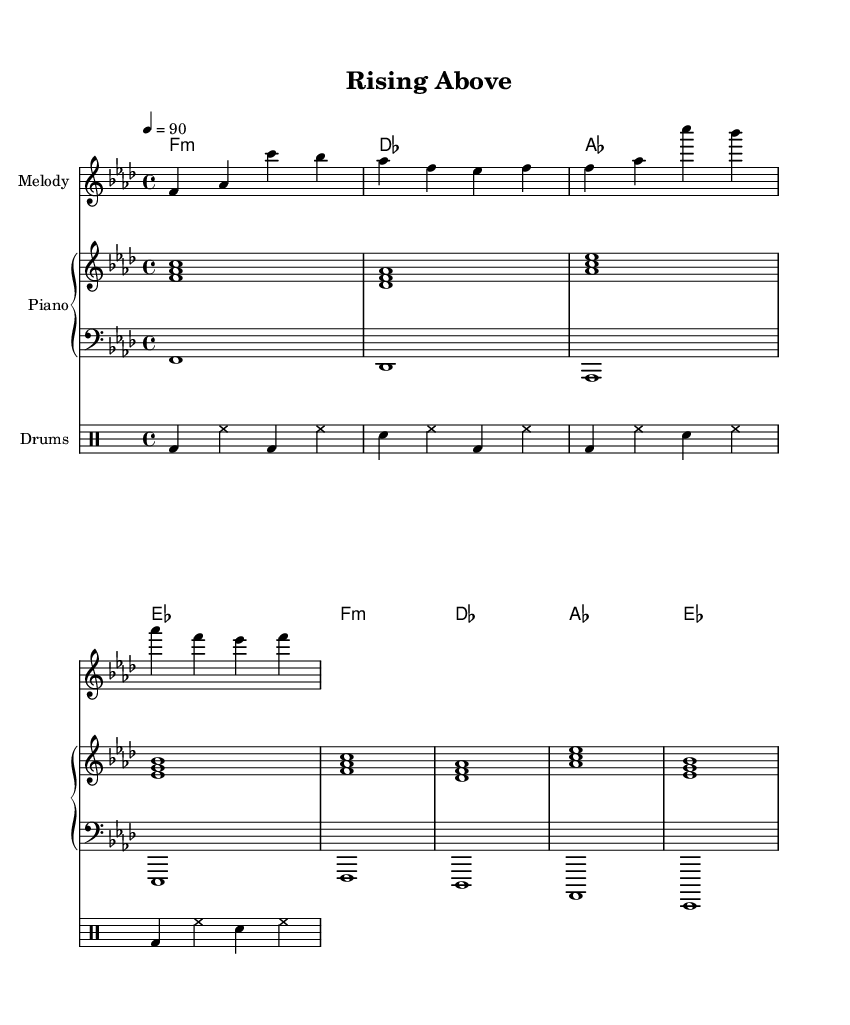what is the key signature of this music? The key signature can be found at the beginning of the piece. It is noted as F minor, which has four flats: B flat, E flat, A flat, and D flat.
Answer: F minor what is the time signature of this music? The time signature is indicated at the beginning of the piece. It is 4/4, meaning there are four beats in each measure, and the quarter note gets one beat.
Answer: 4/4 what is the indicated tempo for this piece? The tempo is typically noted above the staff. In this case, it is marked as 90 beats per minute, indicating a steady pace for the performers.
Answer: 90 how many measures are in the melody section? The melody section contains four measures as indicated by the grouping of bars. Counting the vertical lines that separate the musical notation gives a total of four.
Answer: 4 what instrument is featured in the melody part? The instrumentation can be identified at the beginning of the staff containing the melody. It is labeled "Melody," but it is often performed on an instrument like a flute or a vocal.
Answer: Melody how does the bass line interact with the chord changes? To analyze the interaction, we look at the bass notes in relation to the harmonies. Each bass note aligns with the chord changes underneath, maintaining the foundational notes of each chord in its respective measures. This connection supports the harmonic structure of the piece.
Answer: Aligned what lyrical themes are expressed in this hip-hop piece? While the sheet music does not display lyrics, analyzing the title "Rising Above" suggests themes of overcoming struggles. In hip-hop, especially conscious hip-hop, such themes often reflect the journey through addiction and the quest for recovery and acceptance.
Answer: Overcoming struggles 